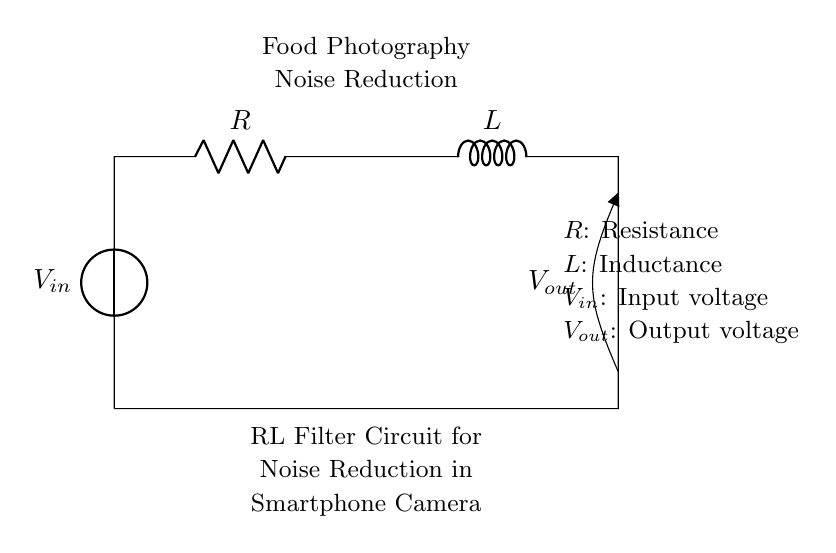What components are in the circuit? The circuit contains a voltage source, a resistor, and an inductor. These components are displayed clearly in the diagram, with their respective symbols and labels.
Answer: Voltage source, resistor, inductor What is the role of the resistor in this circuit? The resistor limits the current in the circuit, influencing the voltage drop across it and the overall behavior of the RL filter. This is important for managing noise reduction in the context of the smartphone camera.
Answer: Current limiting What happens to the output voltage if the inductance increases? Increasing the inductance will cause the output voltage to vary more slowly when the input changes, resulting in better noise filtering. This is because a larger inductor opposes changes in current more effectively.
Answer: Output voltage decreases What is the purpose of this RL filter circuit in smartphone cameras? The RL filter circuit is designed to reduce unwanted noise in food photography, improving image quality by filtering out high-frequency noise signals that may interfere with the captured image.
Answer: Noise reduction What is the expected behavior of the output voltage when the input voltage rapidly changes? The output voltage will change more slowly than the input due to the inductor's tendency to oppose sudden changes in current. This behavior is indicative of the smoothing action that an RL filter provides.
Answer: Smoother output 